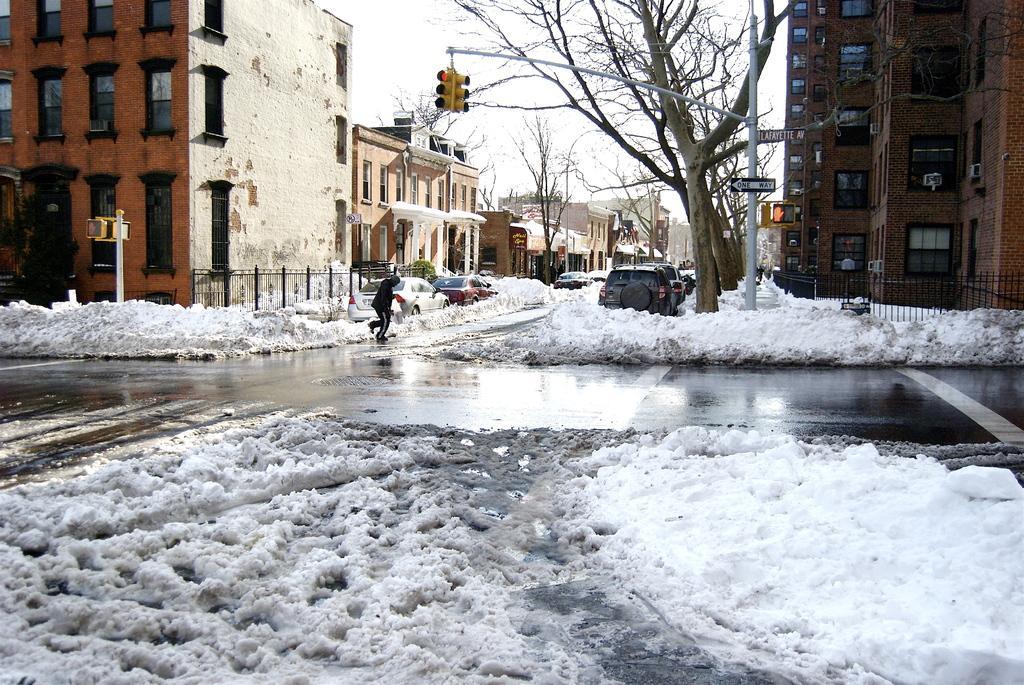In one or two sentences, can you explain what this image depicts? In this image the road is covered with snow and there are cars on the road and a man is walking, in the background there are buildings, trees, signal poles and the sky. 